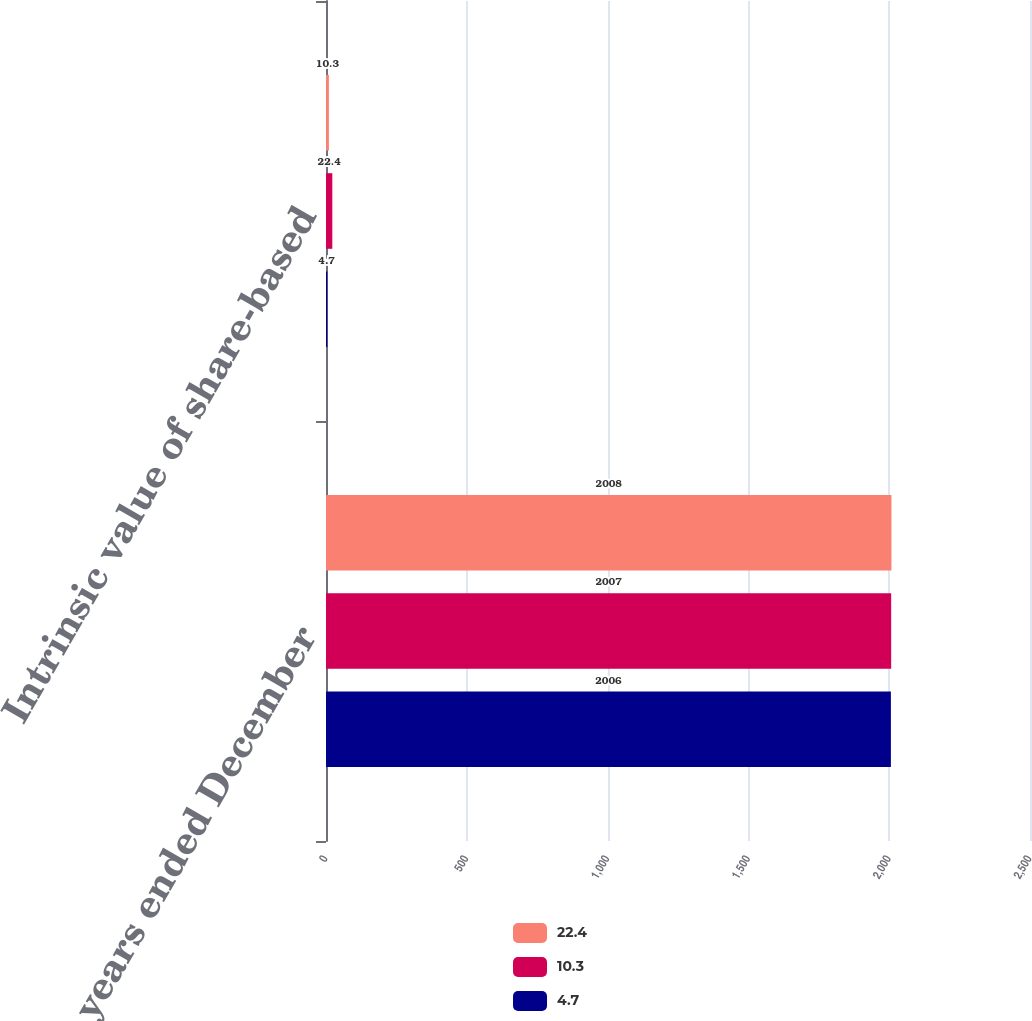<chart> <loc_0><loc_0><loc_500><loc_500><stacked_bar_chart><ecel><fcel>For the years ended December<fcel>Intrinsic value of share-based<nl><fcel>22.4<fcel>2008<fcel>10.3<nl><fcel>10.3<fcel>2007<fcel>22.4<nl><fcel>4.7<fcel>2006<fcel>4.7<nl></chart> 